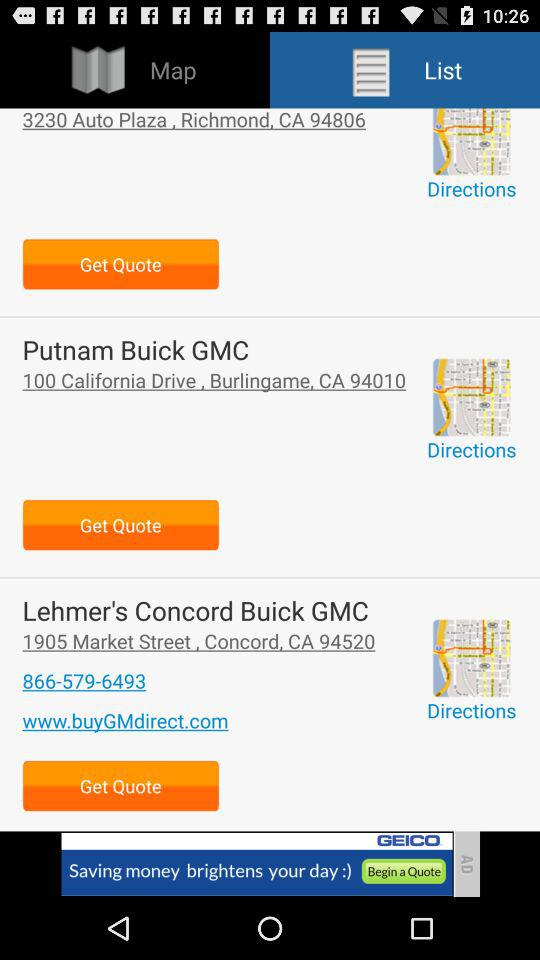What is the address of "Lehmer's Concord Buick GMC"? The address of "Lehmer's Concord Buick GMC" is 1905 Market Street, Concord, CA 94520. 